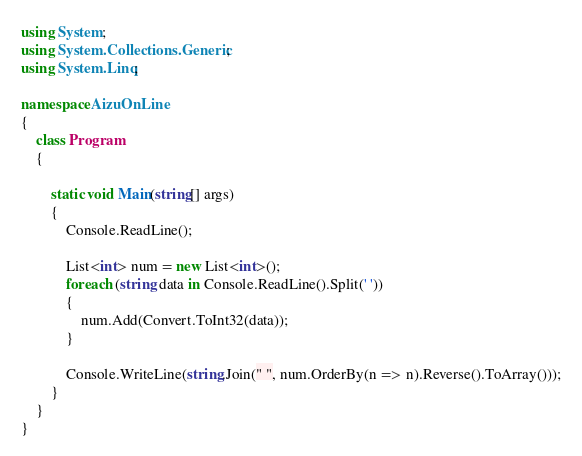<code> <loc_0><loc_0><loc_500><loc_500><_C#_>using System;
using System.Collections.Generic;
using System.Linq;

namespace AizuOnLine
{
    class Program
    {

        static void Main(string[] args)
        {
            Console.ReadLine();

            List<int> num = new List<int>();
            foreach (string data in Console.ReadLine().Split(' '))
            {
                num.Add(Convert.ToInt32(data));
            }

            Console.WriteLine(string.Join(" ", num.OrderBy(n => n).Reverse().ToArray()));
        }
    }
}</code> 